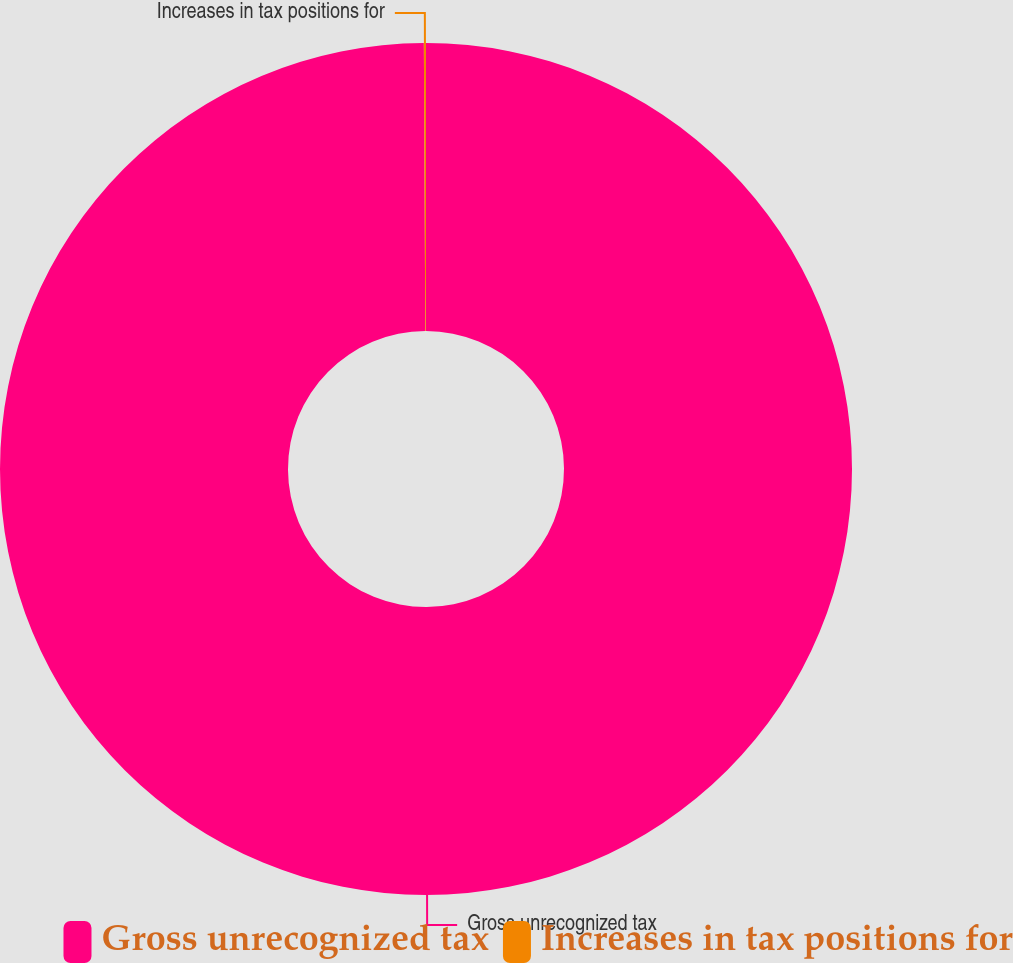Convert chart. <chart><loc_0><loc_0><loc_500><loc_500><pie_chart><fcel>Gross unrecognized tax<fcel>Increases in tax positions for<nl><fcel>99.92%<fcel>0.08%<nl></chart> 